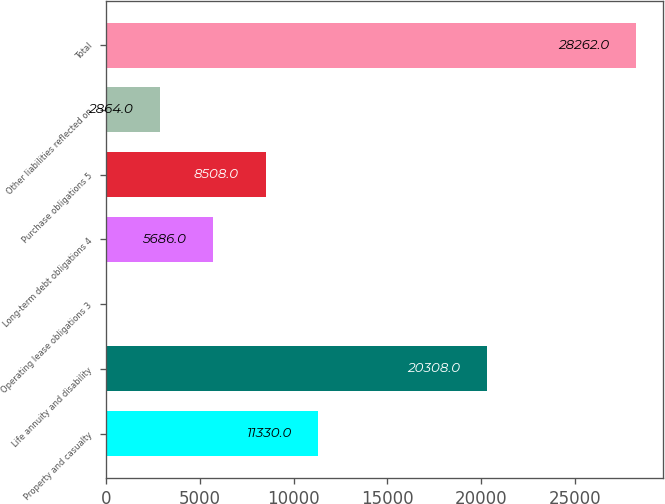<chart> <loc_0><loc_0><loc_500><loc_500><bar_chart><fcel>Property and casualty<fcel>Life annuity and disability<fcel>Operating lease obligations 3<fcel>Long-term debt obligations 4<fcel>Purchase obligations 5<fcel>Other liabilities reflected on<fcel>Total<nl><fcel>11330<fcel>20308<fcel>42<fcel>5686<fcel>8508<fcel>2864<fcel>28262<nl></chart> 